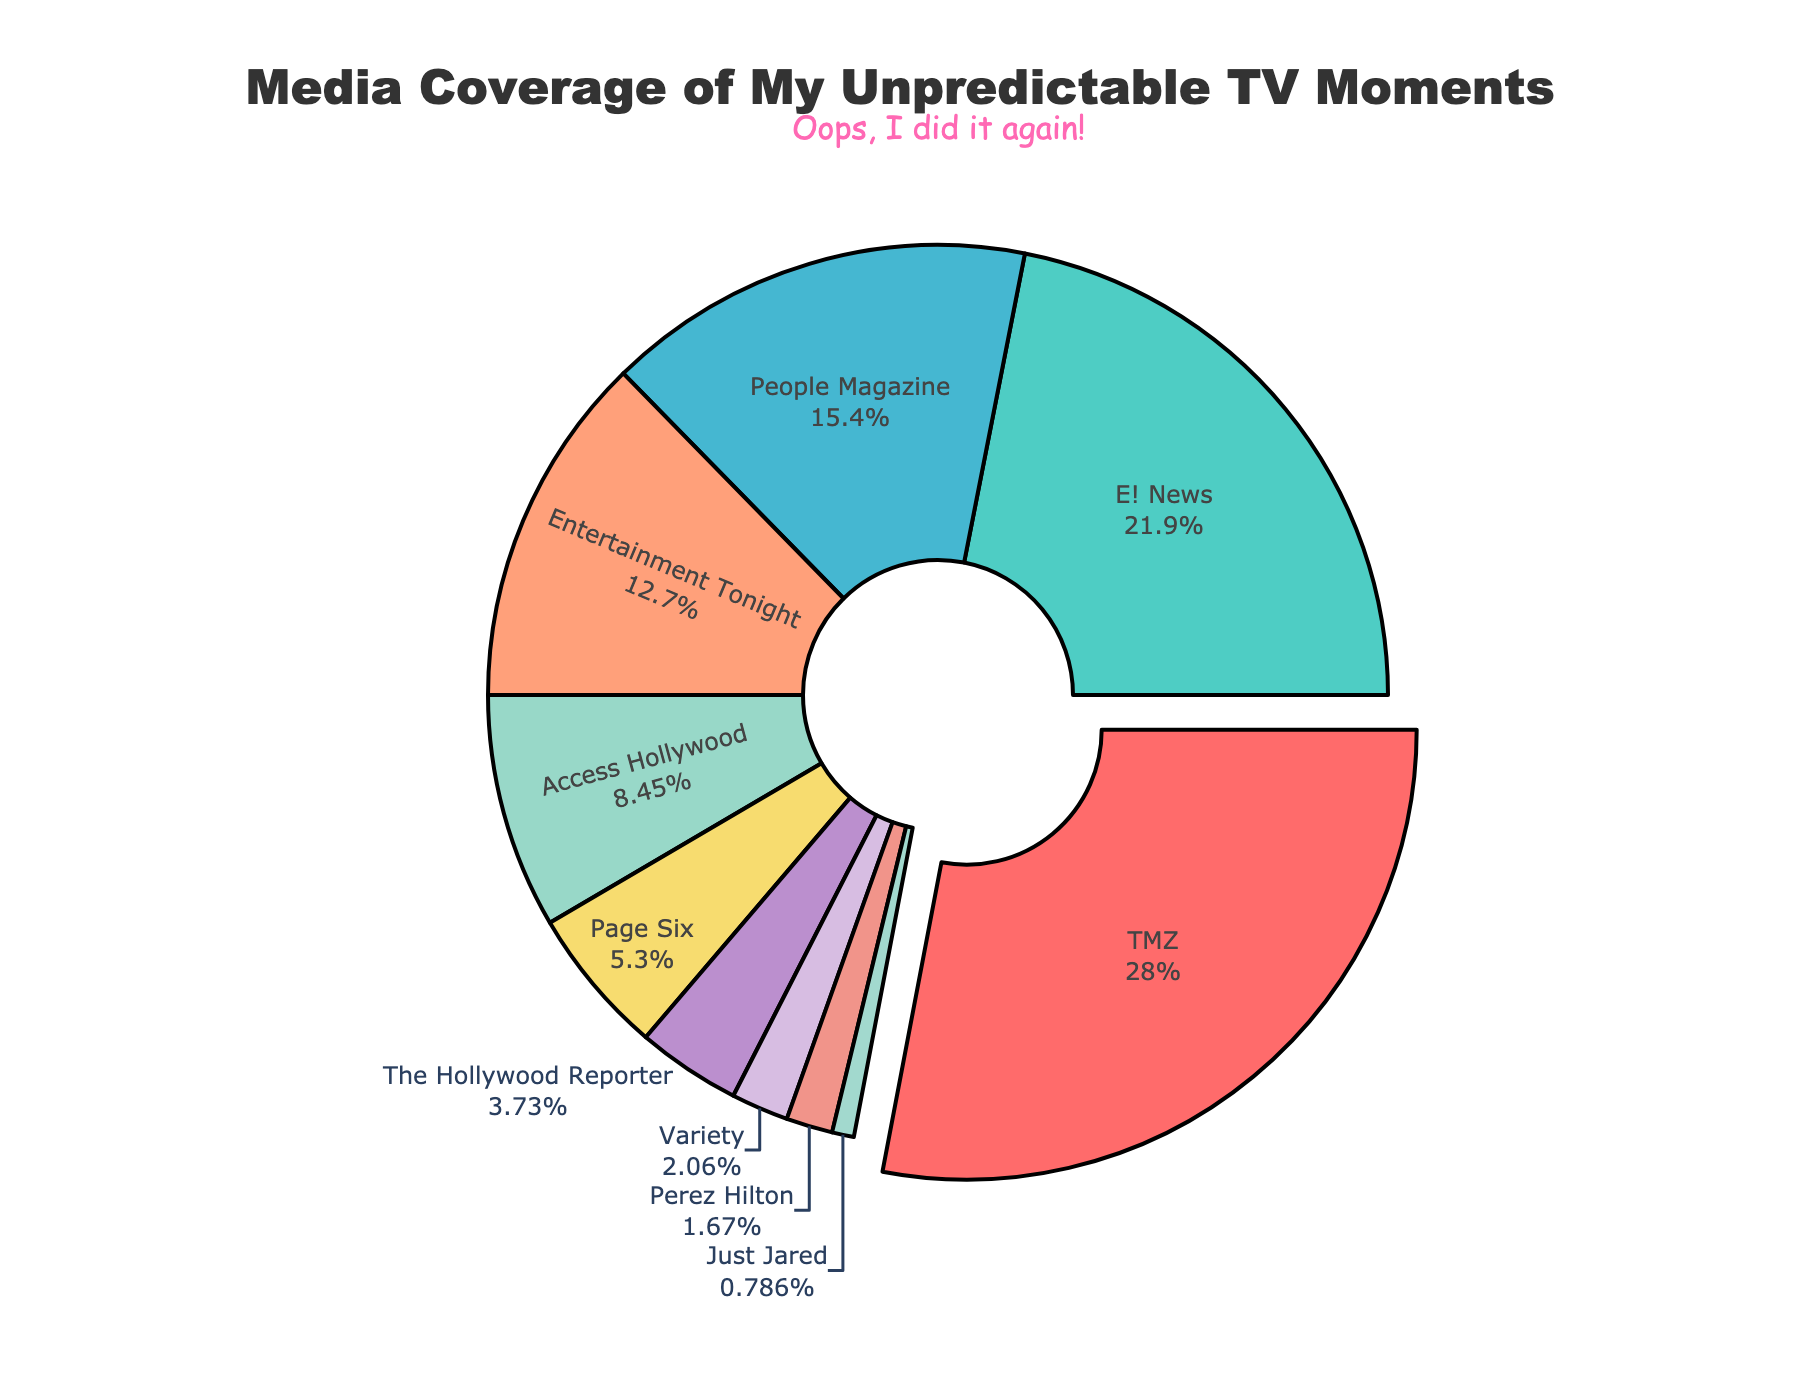Which entertainment outlet has the largest share of media coverage? The largest share can be identified by the segment with the highest percentage. It is also visually emphasized by being slightly pulled out from the pie chart.
Answer: TMZ How much is the combined coverage percentage of People Magazine and Entertainment Tonight? To find the combined percentage, add the coverage percentages of People Magazine (15.7%) and Entertainment Tonight (12.9%). The sum is 15.7 + 12.9 = 28.6%.
Answer: 28.6% Which two entertainment outlets have nearly equal media coverage percentages? By comparing the coverage percentages of the outlets, we can see that Page Six (5.4%) and The Hollywood Reporter (3.8%) are relatively close to each other.
Answer: Page Six and The Hollywood Reporter Which entertainment outlet has the smallest share of coverage? The smallest share can be identified by the segment with the lowest percentage. This is the smallest slice in the pie chart.
Answer: Just Jared What is the difference in coverage percentage between E! News and Access Hollywood? The difference is found by subtracting Access Hollywood's percentage (8.6%) from E! News's percentage (22.3%). The difference is 22.3 - 8.6 = 13.7%.
Answer: 13.7% What percentage of coverage is represented by outlets covering less than 5%? Outlets with coverage less than 5% include Page Six (5.4), The Hollywood Reporter (3.8), Variety (2.1), Perez Hilton (1.7), and Just Jared (0.8). Add their percentages: 5.4 + 3.8 + 2.1 + 1.7 + 0.8 = 13.8%.
Answer: 13.8% Which outlet is represented by the turquoise color in the pie chart? By observing the colors associated with each slice of the pie, we can identify that E! News is represented by the turquoise color.
Answer: E! News How much more coverage does TMZ have compared to People Magazine? Subtract People Magazine's percentage (15.7%) from TMZ's percentage (28.5%) to find the difference. The calculation is 28.5 - 15.7 = 12.8%.
Answer: 12.8% Which outlet has a pink color and what is its corresponding coverage percentage? The slice with the pink color corresponds to the outlet with 8.6% coverage. The pink section represents Access Hollywood.
Answer: Access Hollywood with 8.6% What is the total coverage percentage of TMZ, E! News, and Entertainment Tonight combined? Add the percentages of TMZ (28.5%), E! News (22.3%), and Entertainment Tonight (12.9%). The sum is 28.5 + 22.3 + 12.9 = 63.7%.
Answer: 63.7% 